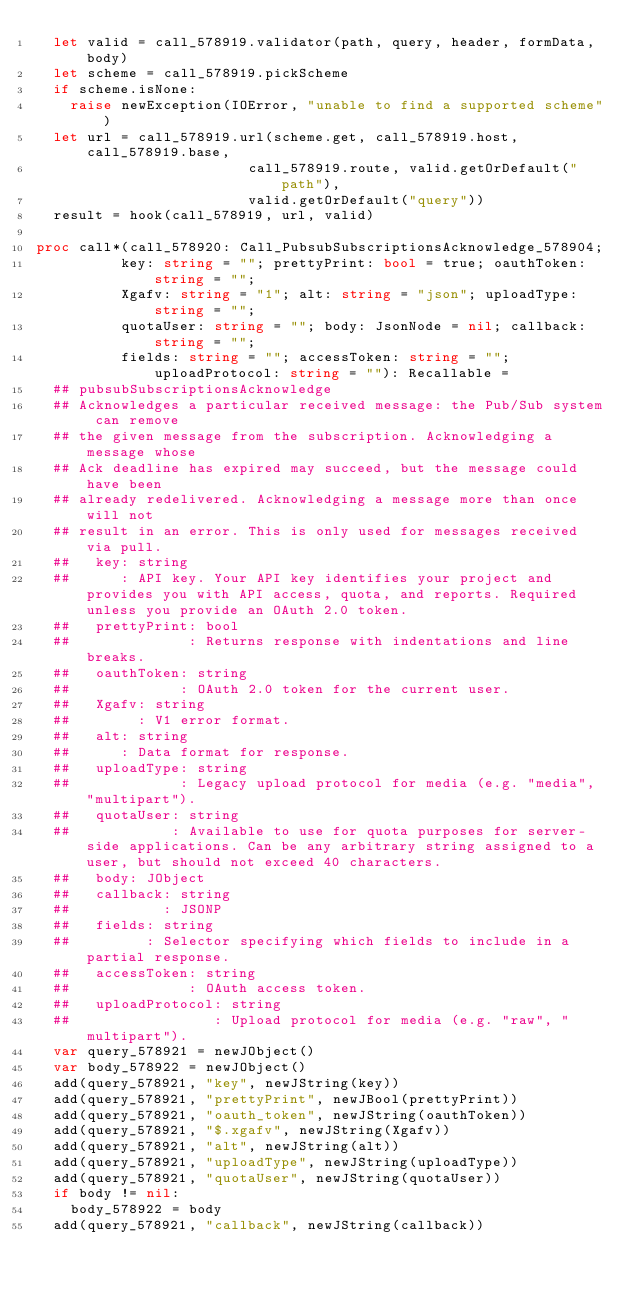Convert code to text. <code><loc_0><loc_0><loc_500><loc_500><_Nim_>  let valid = call_578919.validator(path, query, header, formData, body)
  let scheme = call_578919.pickScheme
  if scheme.isNone:
    raise newException(IOError, "unable to find a supported scheme")
  let url = call_578919.url(scheme.get, call_578919.host, call_578919.base,
                         call_578919.route, valid.getOrDefault("path"),
                         valid.getOrDefault("query"))
  result = hook(call_578919, url, valid)

proc call*(call_578920: Call_PubsubSubscriptionsAcknowledge_578904;
          key: string = ""; prettyPrint: bool = true; oauthToken: string = "";
          Xgafv: string = "1"; alt: string = "json"; uploadType: string = "";
          quotaUser: string = ""; body: JsonNode = nil; callback: string = "";
          fields: string = ""; accessToken: string = ""; uploadProtocol: string = ""): Recallable =
  ## pubsubSubscriptionsAcknowledge
  ## Acknowledges a particular received message: the Pub/Sub system can remove
  ## the given message from the subscription. Acknowledging a message whose
  ## Ack deadline has expired may succeed, but the message could have been
  ## already redelivered. Acknowledging a message more than once will not
  ## result in an error. This is only used for messages received via pull.
  ##   key: string
  ##      : API key. Your API key identifies your project and provides you with API access, quota, and reports. Required unless you provide an OAuth 2.0 token.
  ##   prettyPrint: bool
  ##              : Returns response with indentations and line breaks.
  ##   oauthToken: string
  ##             : OAuth 2.0 token for the current user.
  ##   Xgafv: string
  ##        : V1 error format.
  ##   alt: string
  ##      : Data format for response.
  ##   uploadType: string
  ##             : Legacy upload protocol for media (e.g. "media", "multipart").
  ##   quotaUser: string
  ##            : Available to use for quota purposes for server-side applications. Can be any arbitrary string assigned to a user, but should not exceed 40 characters.
  ##   body: JObject
  ##   callback: string
  ##           : JSONP
  ##   fields: string
  ##         : Selector specifying which fields to include in a partial response.
  ##   accessToken: string
  ##              : OAuth access token.
  ##   uploadProtocol: string
  ##                 : Upload protocol for media (e.g. "raw", "multipart").
  var query_578921 = newJObject()
  var body_578922 = newJObject()
  add(query_578921, "key", newJString(key))
  add(query_578921, "prettyPrint", newJBool(prettyPrint))
  add(query_578921, "oauth_token", newJString(oauthToken))
  add(query_578921, "$.xgafv", newJString(Xgafv))
  add(query_578921, "alt", newJString(alt))
  add(query_578921, "uploadType", newJString(uploadType))
  add(query_578921, "quotaUser", newJString(quotaUser))
  if body != nil:
    body_578922 = body
  add(query_578921, "callback", newJString(callback))</code> 